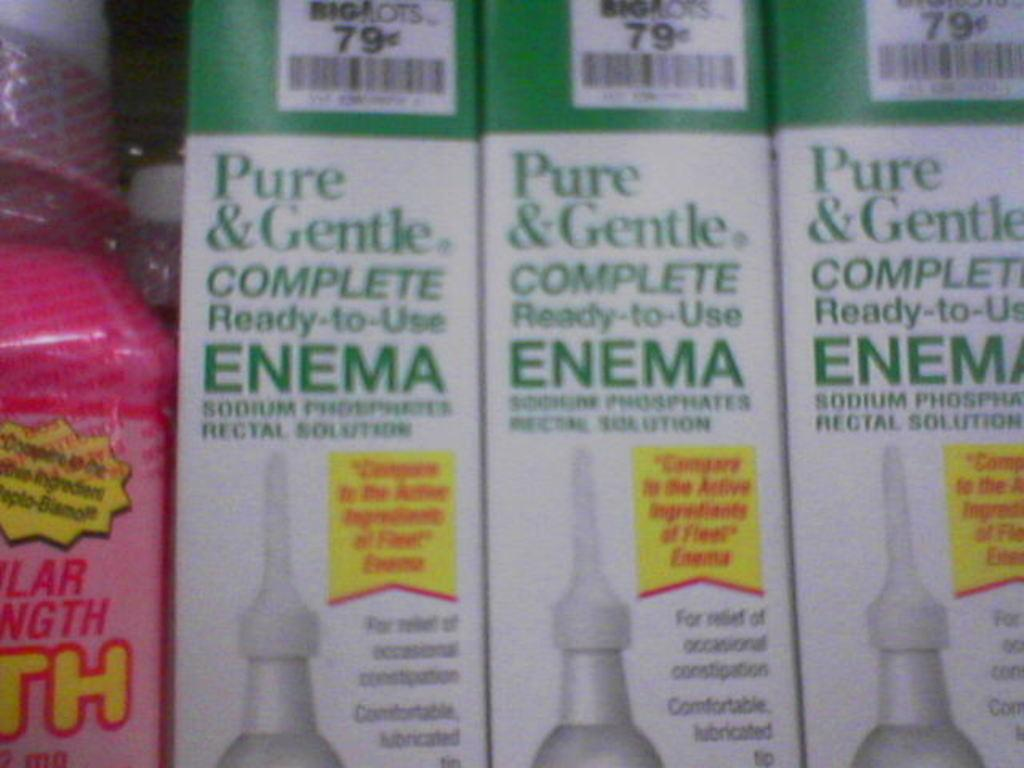What color of the bottle in the image? There is a pink color bottle in the image. What is written on the bottle? There is text on the bottle. How many boxes are visible in the image? There are three boxes in the image. What is written on the boxes? There is text on the boxes. What additional feature can be seen on the boxes? There are barcodes on the boxes. Is there a cherry smashed by fire in the image? There is no cherry, smashing, or fire present in the image. 